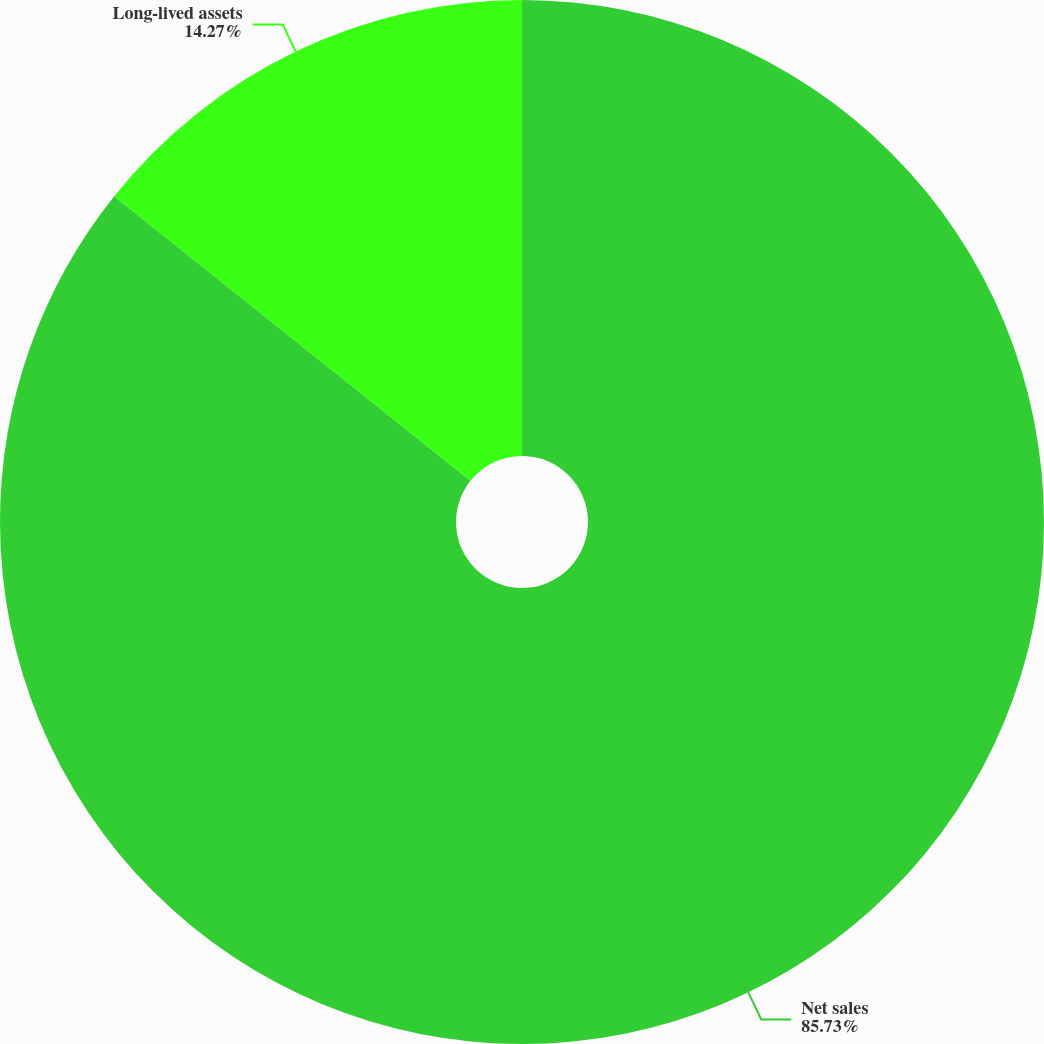<chart> <loc_0><loc_0><loc_500><loc_500><pie_chart><fcel>Net sales<fcel>Long-lived assets<nl><fcel>85.73%<fcel>14.27%<nl></chart> 